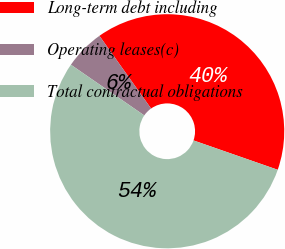<chart> <loc_0><loc_0><loc_500><loc_500><pie_chart><fcel>Long-term debt including<fcel>Operating leases(c)<fcel>Total contractual obligations<nl><fcel>40.17%<fcel>5.55%<fcel>54.29%<nl></chart> 